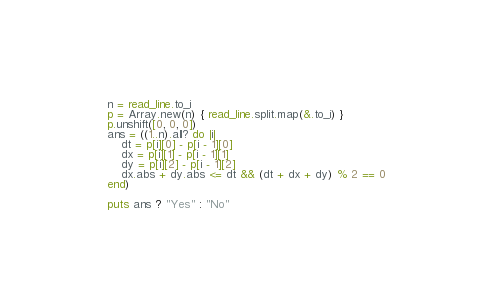<code> <loc_0><loc_0><loc_500><loc_500><_Crystal_>n = read_line.to_i
p = Array.new(n) { read_line.split.map(&.to_i) }
p.unshift([0, 0, 0])
ans = ((1..n).all? do |i|
    dt = p[i][0] - p[i - 1][0]
    dx = p[i][1] - p[i - 1][1]
    dy = p[i][2] - p[i - 1][2]
    dx.abs + dy.abs <= dt && (dt + dx + dy) % 2 == 0
end)

puts ans ? "Yes" : "No"
</code> 